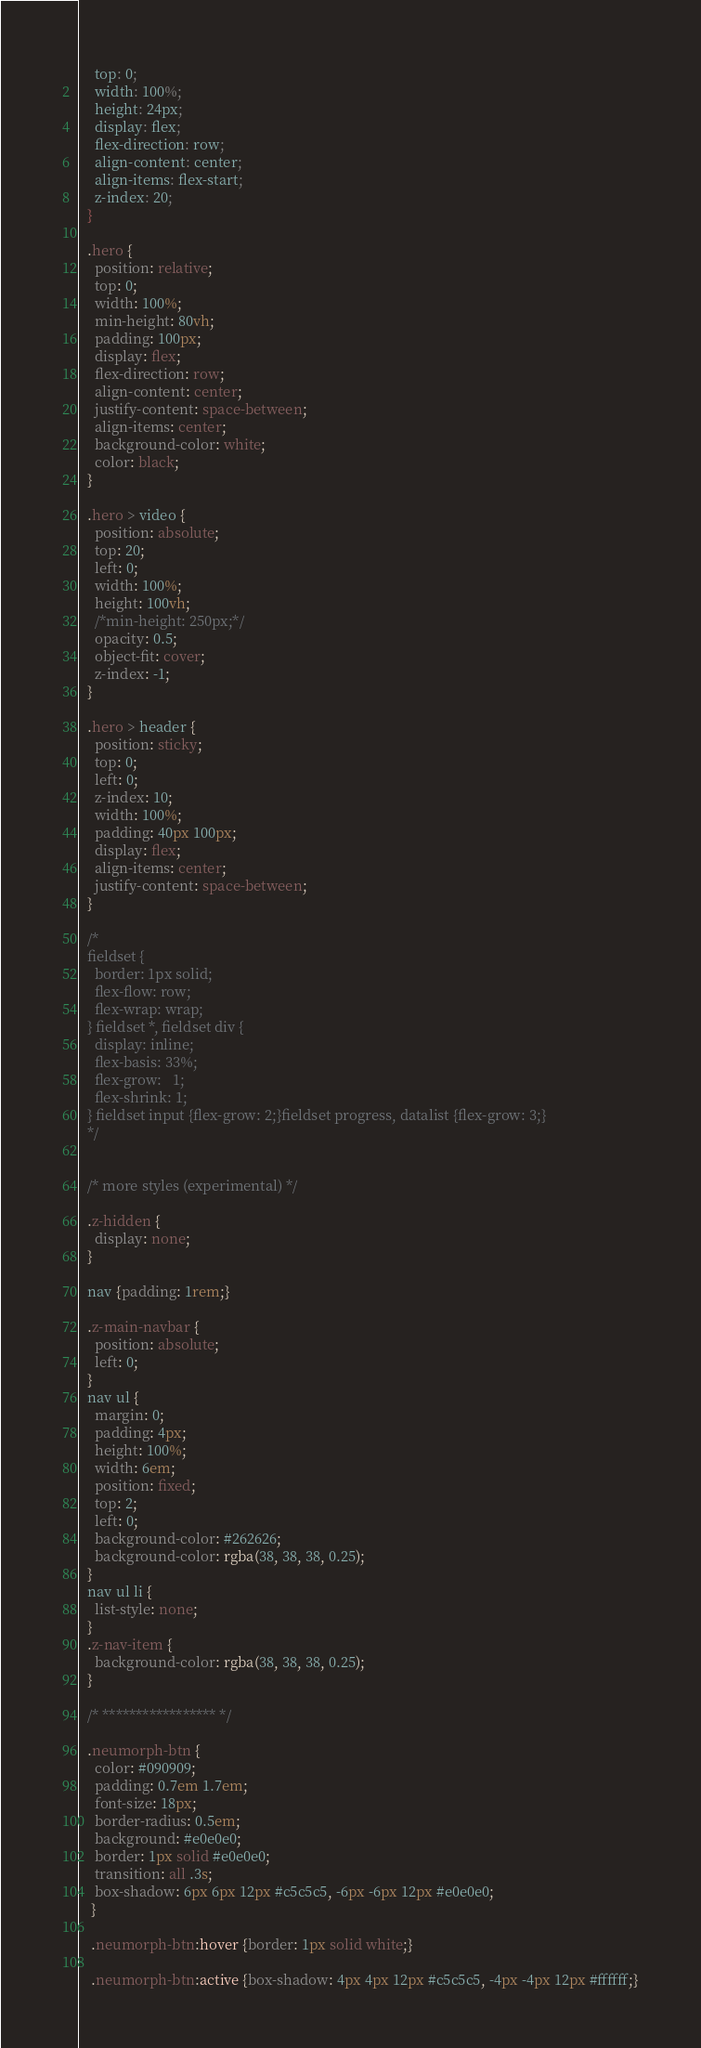<code> <loc_0><loc_0><loc_500><loc_500><_CSS_>    top: 0;
    width: 100%;
    height: 24px;
    display: flex;
    flex-direction: row;
    align-content: center;
    align-items: flex-start;
    z-index: 20;
  }

  .hero {
    position: relative;
    top: 0;
    width: 100%;
    min-height: 80vh;
    padding: 100px;
    display: flex;
    flex-direction: row;
    align-content: center;
    justify-content: space-between;
    align-items: center;
    background-color: white;
    color: black;
  }

  .hero > video {
    position: absolute;
    top: 20;
    left: 0;
    width: 100%;
    height: 100vh;
    /*min-height: 250px;*/
    opacity: 0.5;
    object-fit: cover;
    z-index: -1;
  }

  .hero > header {
    position: sticky;
    top: 0;
    left: 0;
    z-index: 10;
    width: 100%;
    padding: 40px 100px;
    display: flex;
    align-items: center;
    justify-content: space-between;
  }

  /*
  fieldset {
    border: 1px solid;
    flex-flow: row;
    flex-wrap: wrap;
  } fieldset *, fieldset div {
    display: inline;
    flex-basis: 33%;
    flex-grow:   1;
    flex-shrink: 1;
  } fieldset input {flex-grow: 2;}fieldset progress, datalist {flex-grow: 3;}
  */


  /* more styles (experimental) */
  
  .z-hidden {
    display: none;
  }

  nav {padding: 1rem;}
  
  .z-main-navbar {
    position: absolute;
    left: 0;
  }
  nav ul {
    margin: 0;
    padding: 4px;
    height: 100%;
    width: 6em;
    position: fixed;
    top: 2;
    left: 0;
    background-color: #262626;
    background-color: rgba(38, 38, 38, 0.25);
  }
  nav ul li {
    list-style: none;
  }
  .z-nav-item {
    background-color: rgba(38, 38, 38, 0.25);
  }

  /* ***************** */

  .neumorph-btn {
    color: #090909;
    padding: 0.7em 1.7em;
    font-size: 18px;
    border-radius: 0.5em;
    background: #e0e0e0;
    border: 1px solid #e0e0e0;
    transition: all .3s;
    box-shadow: 6px 6px 12px #c5c5c5, -6px -6px 12px #e0e0e0;
   }
   
   .neumorph-btn:hover {border: 1px solid white;}
   
   .neumorph-btn:active {box-shadow: 4px 4px 12px #c5c5c5, -4px -4px 12px #ffffff;}


</code> 